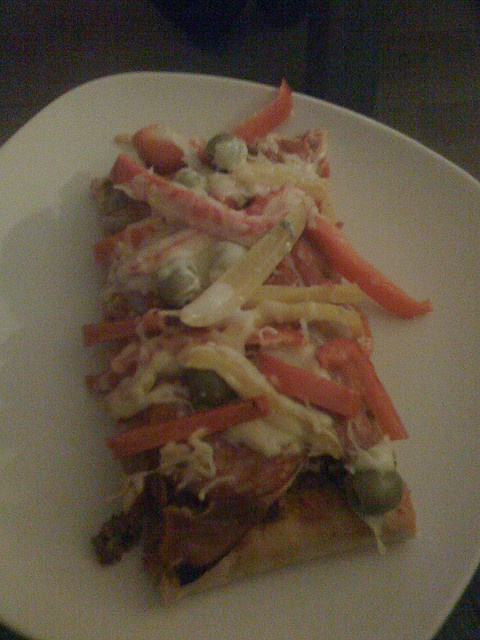Describe the objects in this image and their specific colors. I can see pizza in black, maroon, olive, and gray tones, carrot in black, maroon, and brown tones, carrot in black, maroon, and purple tones, carrot in black, brown, and maroon tones, and carrot in black, maroon, and brown tones in this image. 